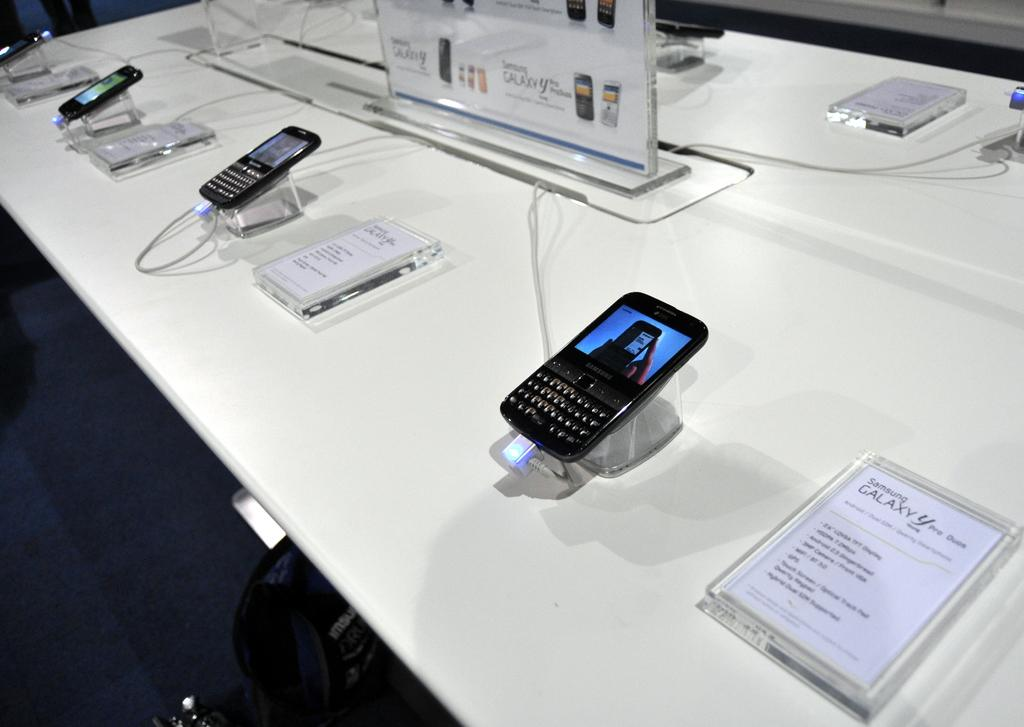<image>
Give a short and clear explanation of the subsequent image. A Samsung Galaxy phone is displayed among others in a store. 